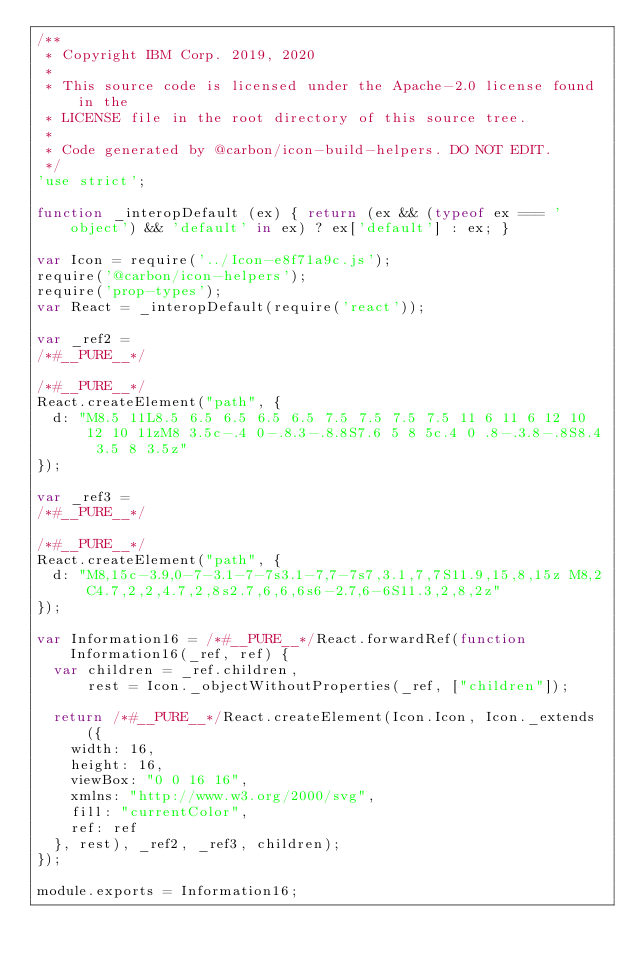<code> <loc_0><loc_0><loc_500><loc_500><_JavaScript_>/**
 * Copyright IBM Corp. 2019, 2020
 *
 * This source code is licensed under the Apache-2.0 license found in the
 * LICENSE file in the root directory of this source tree.
 *
 * Code generated by @carbon/icon-build-helpers. DO NOT EDIT.
 */
'use strict';

function _interopDefault (ex) { return (ex && (typeof ex === 'object') && 'default' in ex) ? ex['default'] : ex; }

var Icon = require('../Icon-e8f71a9c.js');
require('@carbon/icon-helpers');
require('prop-types');
var React = _interopDefault(require('react'));

var _ref2 =
/*#__PURE__*/

/*#__PURE__*/
React.createElement("path", {
  d: "M8.5 11L8.5 6.5 6.5 6.5 6.5 7.5 7.5 7.5 7.5 11 6 11 6 12 10 12 10 11zM8 3.5c-.4 0-.8.3-.8.8S7.6 5 8 5c.4 0 .8-.3.8-.8S8.4 3.5 8 3.5z"
});

var _ref3 =
/*#__PURE__*/

/*#__PURE__*/
React.createElement("path", {
  d: "M8,15c-3.9,0-7-3.1-7-7s3.1-7,7-7s7,3.1,7,7S11.9,15,8,15z M8,2C4.7,2,2,4.7,2,8s2.7,6,6,6s6-2.7,6-6S11.3,2,8,2z"
});

var Information16 = /*#__PURE__*/React.forwardRef(function Information16(_ref, ref) {
  var children = _ref.children,
      rest = Icon._objectWithoutProperties(_ref, ["children"]);

  return /*#__PURE__*/React.createElement(Icon.Icon, Icon._extends({
    width: 16,
    height: 16,
    viewBox: "0 0 16 16",
    xmlns: "http://www.w3.org/2000/svg",
    fill: "currentColor",
    ref: ref
  }, rest), _ref2, _ref3, children);
});

module.exports = Information16;
</code> 